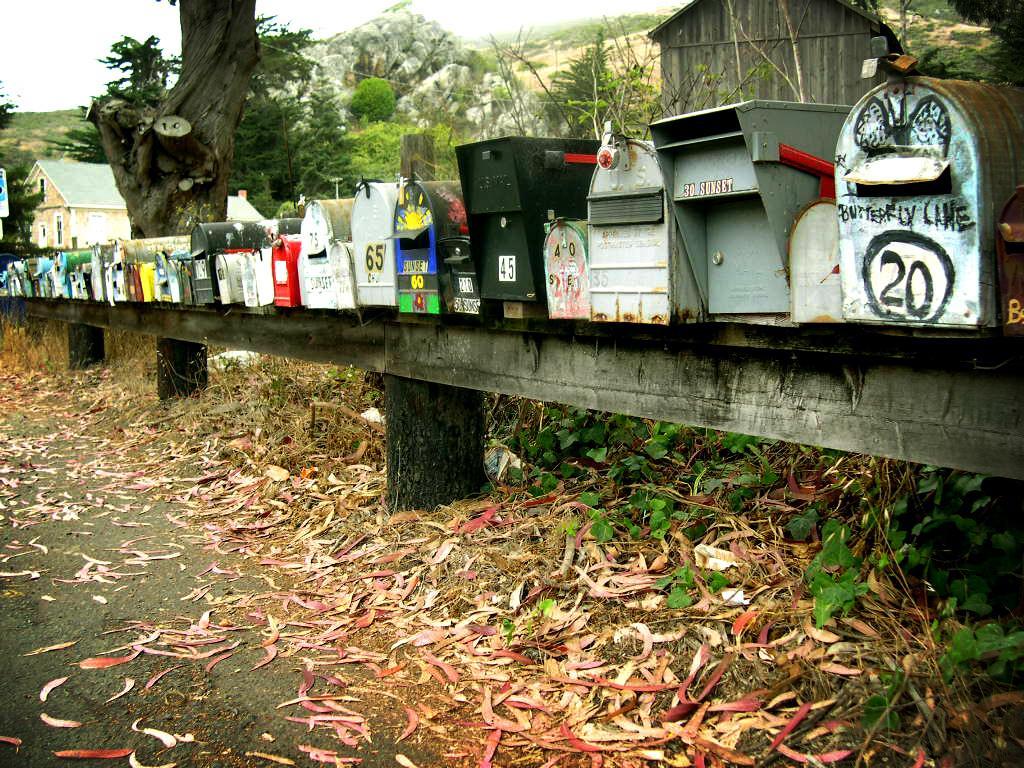Describe this image in one or two sentences. In this picture we can see some leaves at the bottom, on the right side there are some boxes, we can see trees and a house in the background, there is the sky at the top of the picture. 